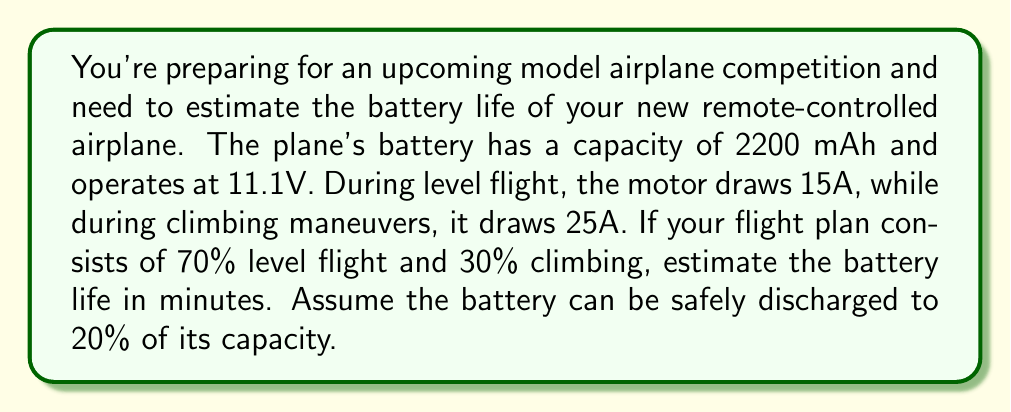Teach me how to tackle this problem. Let's approach this step-by-step:

1) First, calculate the total energy in the battery:
   $E_{total} = 2200 \text{ mAh} \times 11.1 \text{ V} = 24420 \text{ mWh}$

2) Calculate the usable energy (80% of total):
   $E_{usable} = 0.8 \times 24420 \text{ mWh} = 19536 \text{ mWh}$

3) Calculate the average current draw:
   $I_{avg} = 0.7 \times 15 \text{ A} + 0.3 \times 25 \text{ A} = 18 \text{ A}$

4) Calculate the power consumption:
   $P = I_{avg} \times V = 18 \text{ A} \times 11.1 \text{ V} = 199.8 \text{ W}$

5) Calculate the battery life in hours:
   $T = \frac{E_{usable}}{P} = \frac{19536 \text{ mWh}}{199.8 \text{ W}} = 0.0978 \text{ h}$

6) Convert to minutes:
   $T_{minutes} = 0.0978 \text{ h} \times 60 \frac{\text{min}}{\text{h}} = 5.87 \text{ minutes}$

Therefore, the estimated battery life is approximately 5.87 minutes.
Answer: 5.87 minutes 